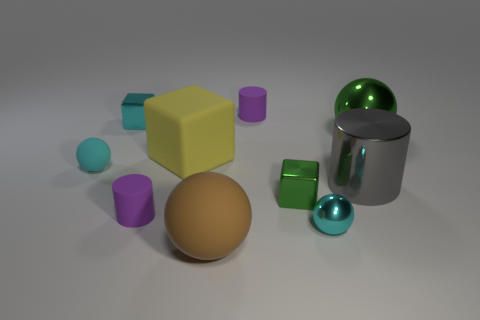Subtract all cyan spheres. How many were subtracted if there are1cyan spheres left? 1 Subtract all cylinders. How many objects are left? 7 Subtract 1 green blocks. How many objects are left? 9 Subtract all tiny gray shiny balls. Subtract all big things. How many objects are left? 6 Add 5 tiny cyan rubber spheres. How many tiny cyan rubber spheres are left? 6 Add 2 big red metallic balls. How many big red metallic balls exist? 2 